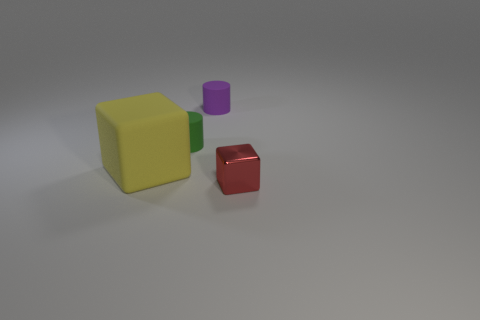There is a rubber cylinder to the right of the green rubber cylinder; what size is it?
Ensure brevity in your answer.  Small. Is the color of the large matte cube the same as the small matte object that is behind the green cylinder?
Make the answer very short. No. Is there a big rubber thing of the same color as the big matte cube?
Make the answer very short. No. Do the small purple object and the thing that is to the left of the tiny green matte thing have the same material?
Provide a succinct answer. Yes. How many tiny objects are either yellow cubes or green shiny balls?
Ensure brevity in your answer.  0. Are there fewer small red metal cubes than large cyan rubber cubes?
Your response must be concise. No. There is a cube behind the tiny cube; does it have the same size as the block right of the big rubber cube?
Your response must be concise. No. What number of green things are cylinders or tiny cubes?
Ensure brevity in your answer.  1. Is the number of big yellow matte objects greater than the number of big cylinders?
Your response must be concise. Yes. Do the tiny metallic cube and the big thing have the same color?
Offer a very short reply. No. 